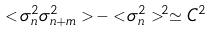Convert formula to latex. <formula><loc_0><loc_0><loc_500><loc_500>< \sigma _ { n } ^ { 2 } \sigma _ { n + m } ^ { 2 } > - < \sigma _ { n } ^ { 2 } > ^ { 2 } \simeq C ^ { 2 }</formula> 